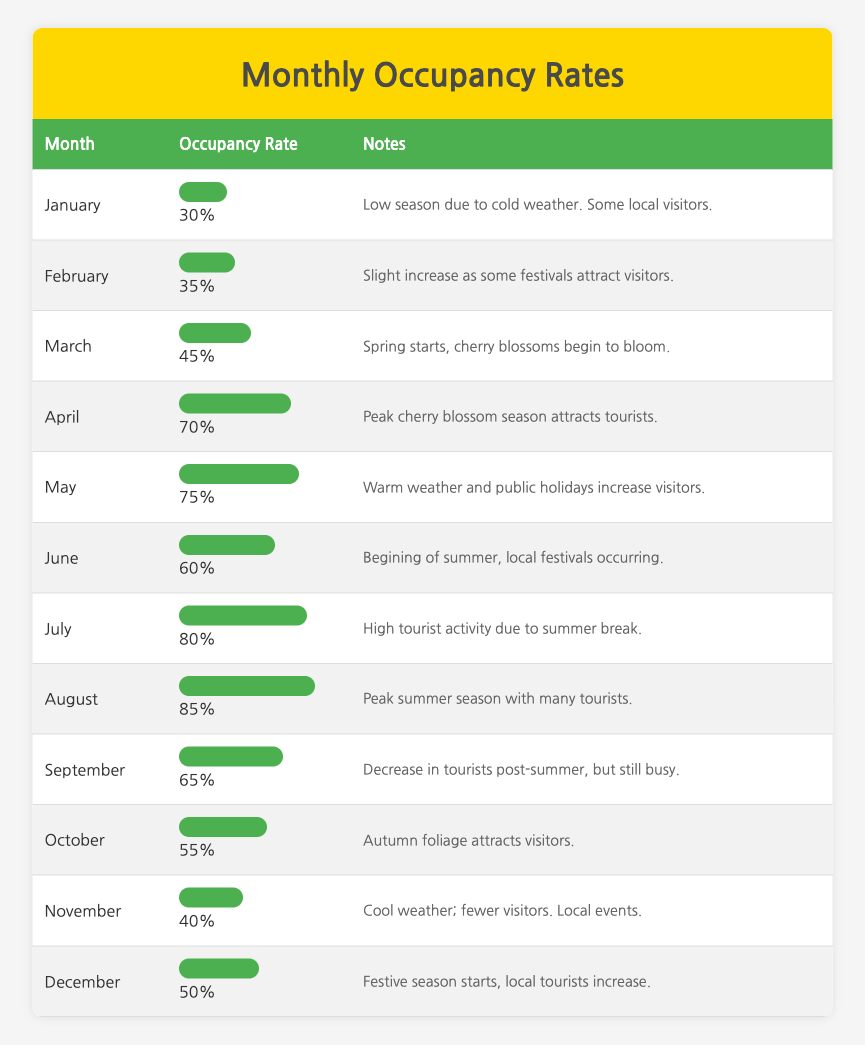What is the occupancy rate for August? The table shows that the occupancy rate for August is 85%. This can be found directly in the row corresponding to August.
Answer: 85% Which month has the lowest occupancy rate? Upon reviewing the table, January has the lowest occupancy rate listed at 30%. This is evident in the first row of the table.
Answer: January What is the average occupancy rate from May to September? To find the average, we add the occupancy rates for each month from May to September: 75 (May) + 80 (July) + 85 (August) + 65 (September) = 305. There are 5 months in total, so we divide the sum by 5: 305/5 = 61.
Answer: 61 Did more tourists visit in July or in April? Looking at the occupancy rates, July has an occupancy rate of 80%, while April has a rate of 70%. Since 80% is greater than 70%, more tourists visited in July.
Answer: Yes, more tourists visited in July What is the difference in occupancy rates between March and November? The occupancy rate for March is 45%, and for November it is 40%. To find the difference, subtract November's rate from March's: 45 - 40 = 5.
Answer: 5 Which months had occupancy rates above 70%? By scanning the table, the months with occupancy rates above 70% are April (70%), May (75%), July (80%), and August (85%). This includes all months listed above 70% in the table.
Answer: April, May, July, August Is the occupancy rate in October greater than 50%? The occupancy rate for October is 55%, which is indeed greater than 50%. The comparison can be directly made using the value in the table.
Answer: Yes What is the total occupancy rate for the first half of the year (January to June)? To get the total occupancy rate for the first half of the year, add the rates from January (30%) + February (35%) + March (45%) + April (70%) + May (75%) + June (60%). This equals 30 + 35 + 45 + 70 + 75 + 60 = 315. To get the average, divide by 6: 315/6 = 52.5.
Answer: 52.5 